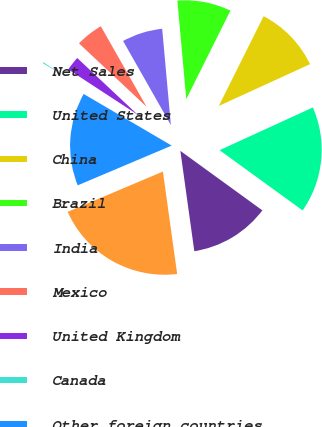Convert chart to OTSL. <chart><loc_0><loc_0><loc_500><loc_500><pie_chart><fcel>Net Sales<fcel>United States<fcel>China<fcel>Brazil<fcel>India<fcel>Mexico<fcel>United Kingdom<fcel>Canada<fcel>Other foreign countries<fcel>Total net sales<nl><fcel>12.81%<fcel>16.82%<fcel>10.8%<fcel>8.8%<fcel>6.79%<fcel>4.78%<fcel>2.78%<fcel>0.77%<fcel>14.81%<fcel>20.83%<nl></chart> 